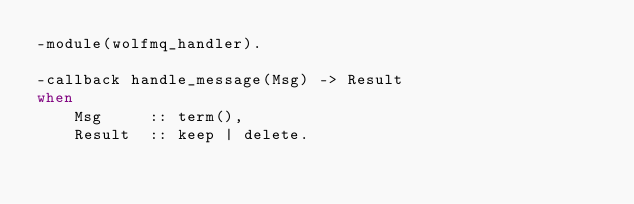Convert code to text. <code><loc_0><loc_0><loc_500><loc_500><_Erlang_>-module(wolfmq_handler).

-callback handle_message(Msg) -> Result
when
    Msg     :: term(),
    Result  :: keep | delete.
</code> 